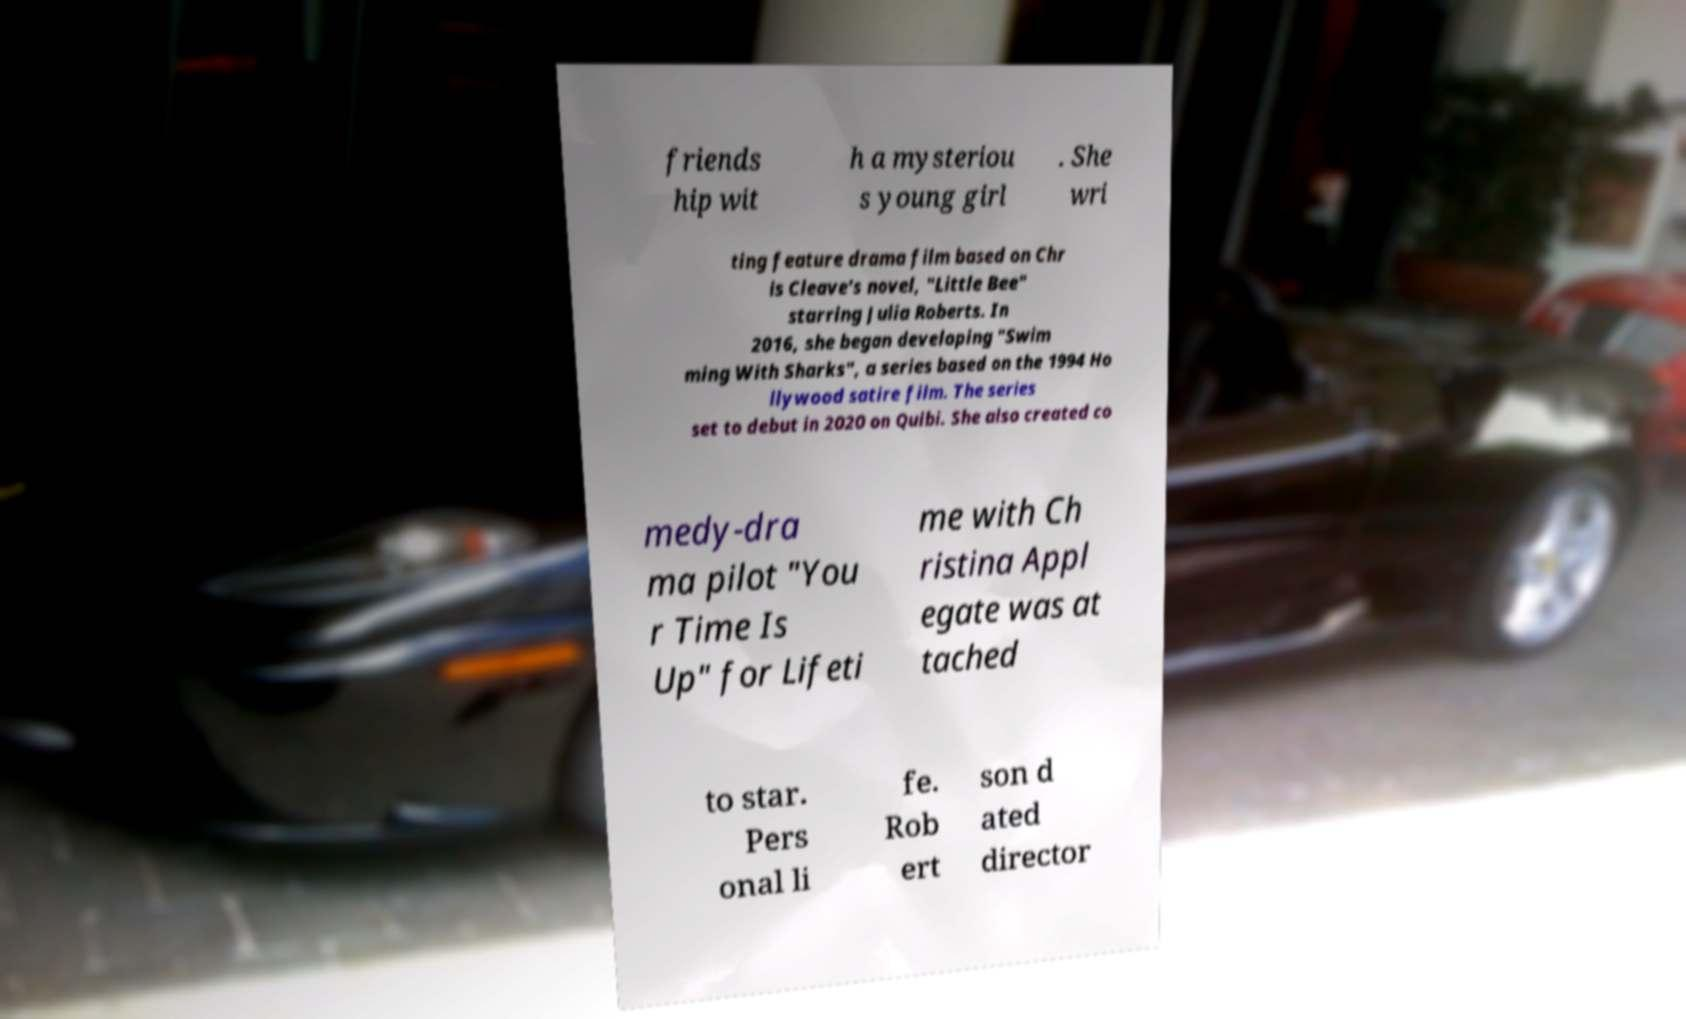There's text embedded in this image that I need extracted. Can you transcribe it verbatim? friends hip wit h a mysteriou s young girl . She wri ting feature drama film based on Chr is Cleave’s novel, "Little Bee" starring Julia Roberts. In 2016, she began developing "Swim ming With Sharks", a series based on the 1994 Ho llywood satire film. The series set to debut in 2020 on Quibi. She also created co medy-dra ma pilot "You r Time Is Up" for Lifeti me with Ch ristina Appl egate was at tached to star. Pers onal li fe. Rob ert son d ated director 